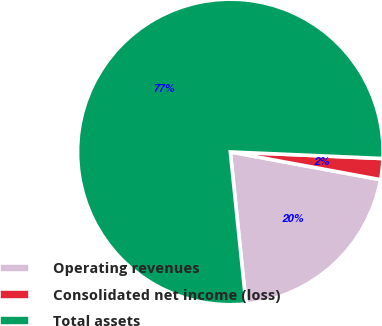Convert chart to OTSL. <chart><loc_0><loc_0><loc_500><loc_500><pie_chart><fcel>Operating revenues<fcel>Consolidated net income (loss)<fcel>Total assets<nl><fcel>20.46%<fcel>2.22%<fcel>77.33%<nl></chart> 